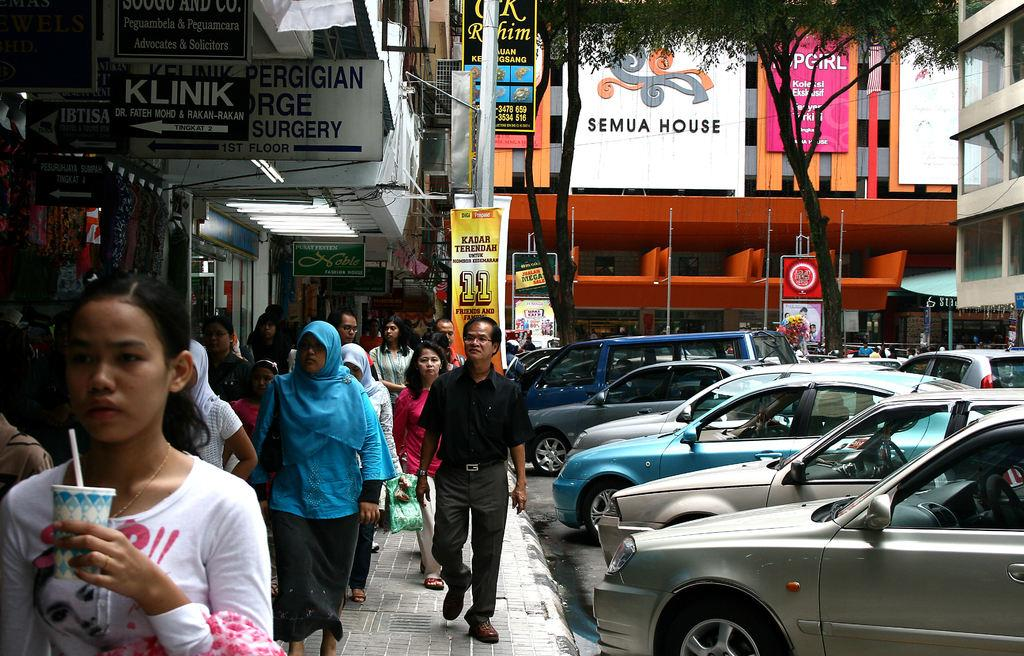Provide a one-sentence caption for the provided image. Pedestrians walk down a crowded sidewalk past a surgery center and a store called Klink. 